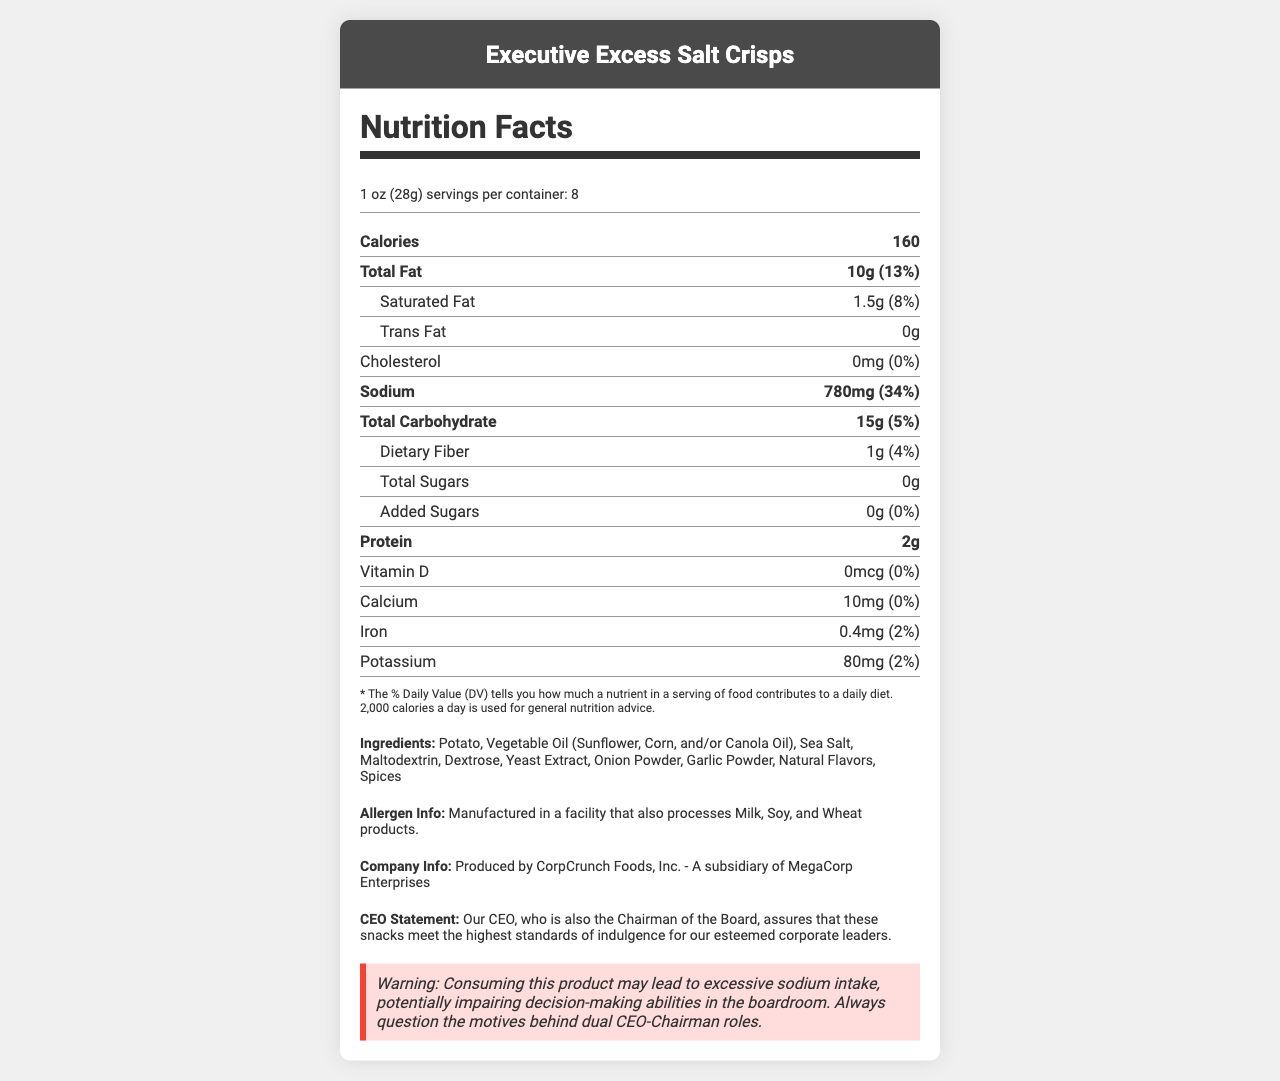what is the serving size for "Executive Excess Salt Crisps"? The serving size is explicitly mentioned in the serving info section as "1 oz (28g)".
Answer: 1 oz (28g) how many servings are in one container? The number of servings per container is listed as "servings per container: 8".
Answer: 8 how much sodium is in one serving? The sodium content per serving is stated as "Sodium: 780mg (34%)".
Answer: 780mg what is the daily value percentage of total fat provided by one serving? The total fat daily value percentage is given as 13% next to the total fat amount (10g).
Answer: 13% name three ingredients in "Executive Excess Salt Crisps". These ingredients are listed among others in the ingredients section.
Answer: Sea Salt, Maltodextrin, Yeast Extract what is the cholesterol content in "Executive Excess Salt Crisps"? The cholesterol amount is indicated as "0mg (0%)".
Answer: 0mg which vitamin is not present in "Executive Excess Salt Crisps"? A. Vitamin A B. Vitamin C C. Vitamin D D. Calcium Vitamin D is listed with an amount of "0mcg (0%)", indicating it is not present.
Answer: C which statement is true about the allergens in "Executive Excess Salt Crisps"? A. Contains Milk B. Manufactured in a facility that processes Soy C. Contains Egg D. Is gluten-free The allergen info states "Manufactured in a facility that also processes Milk, Soy, and Wheat products."
Answer: B are "Executive Excess Salt Crisps" a good source of protein? The protein content is only 2g per serving, which is relatively low.
Answer: No what is the CEO's role apart from being the CEO according to the document? The CEO statement mentions that the CEO is also the Chairman of the Board.
Answer: Chairman of the Board summarize the main idea of the document. The document is mainly about the nutrition facts, ingredients, allergen information, company details, and a warning regarding high sodium content of the "Executive Excess Salt Crisps".
Answer: The document provides detailed nutritional information about "Executive Excess Salt Crisps", a luxury snack with high sodium content, produced by CorpCrunch Foods, Inc. It highlights ingredients, allergen information, and includes a statement from the dual-role CEO/Chairman, noting the high standards of indulgence. There is also a warning about the potential health risks associated with excessive sodium intake. is the product free from added sugars? The amount of added sugars is listed as "0g (0%)", indicating it is free from added sugars.
Answer: Yes what is the purpose of the warning at the end of the document? The warning states, "Consuming this product may lead to excessive sodium intake, potentially impairing decision-making abilities in the boardroom. Always question the motives behind dual CEO-Chairman roles."
Answer: To caution about excessive sodium intake and the implications of the CEO holding dual roles how many calories are provided by one serving of "Executive Excess Salt Crisps"? The calorie content per serving is clearly stated as "Calories: 160".
Answer: 160 what is the amount of potassium in one serving of "Executive Excess Salt Crisps"? The potassium content per serving is listed as "Potassium: 80mg (2%)".
Answer: 80mg what percentage of daily value for iron is provided by one serving? The percentage of daily value for iron is given as "Iron: 0.4mg (2%)".
Answer: 2% where are the "Executive Excess Salt Crisps" produced? This information is found under the company info section of the document.
Answer: Produced by CorpCrunch Foods, Inc. - A subsidiary of MegaCorp Enterprises how much dietary fiber is in one serving of the product? The amount of dietary fiber per serving is listed as "Dietary Fiber: 1g (4%)".
Answer: 1g why is there no detailed nutritional information about phosphorous? The document does not provide any details about phosphorous content, if any, in the product.
Answer: Not enough information 